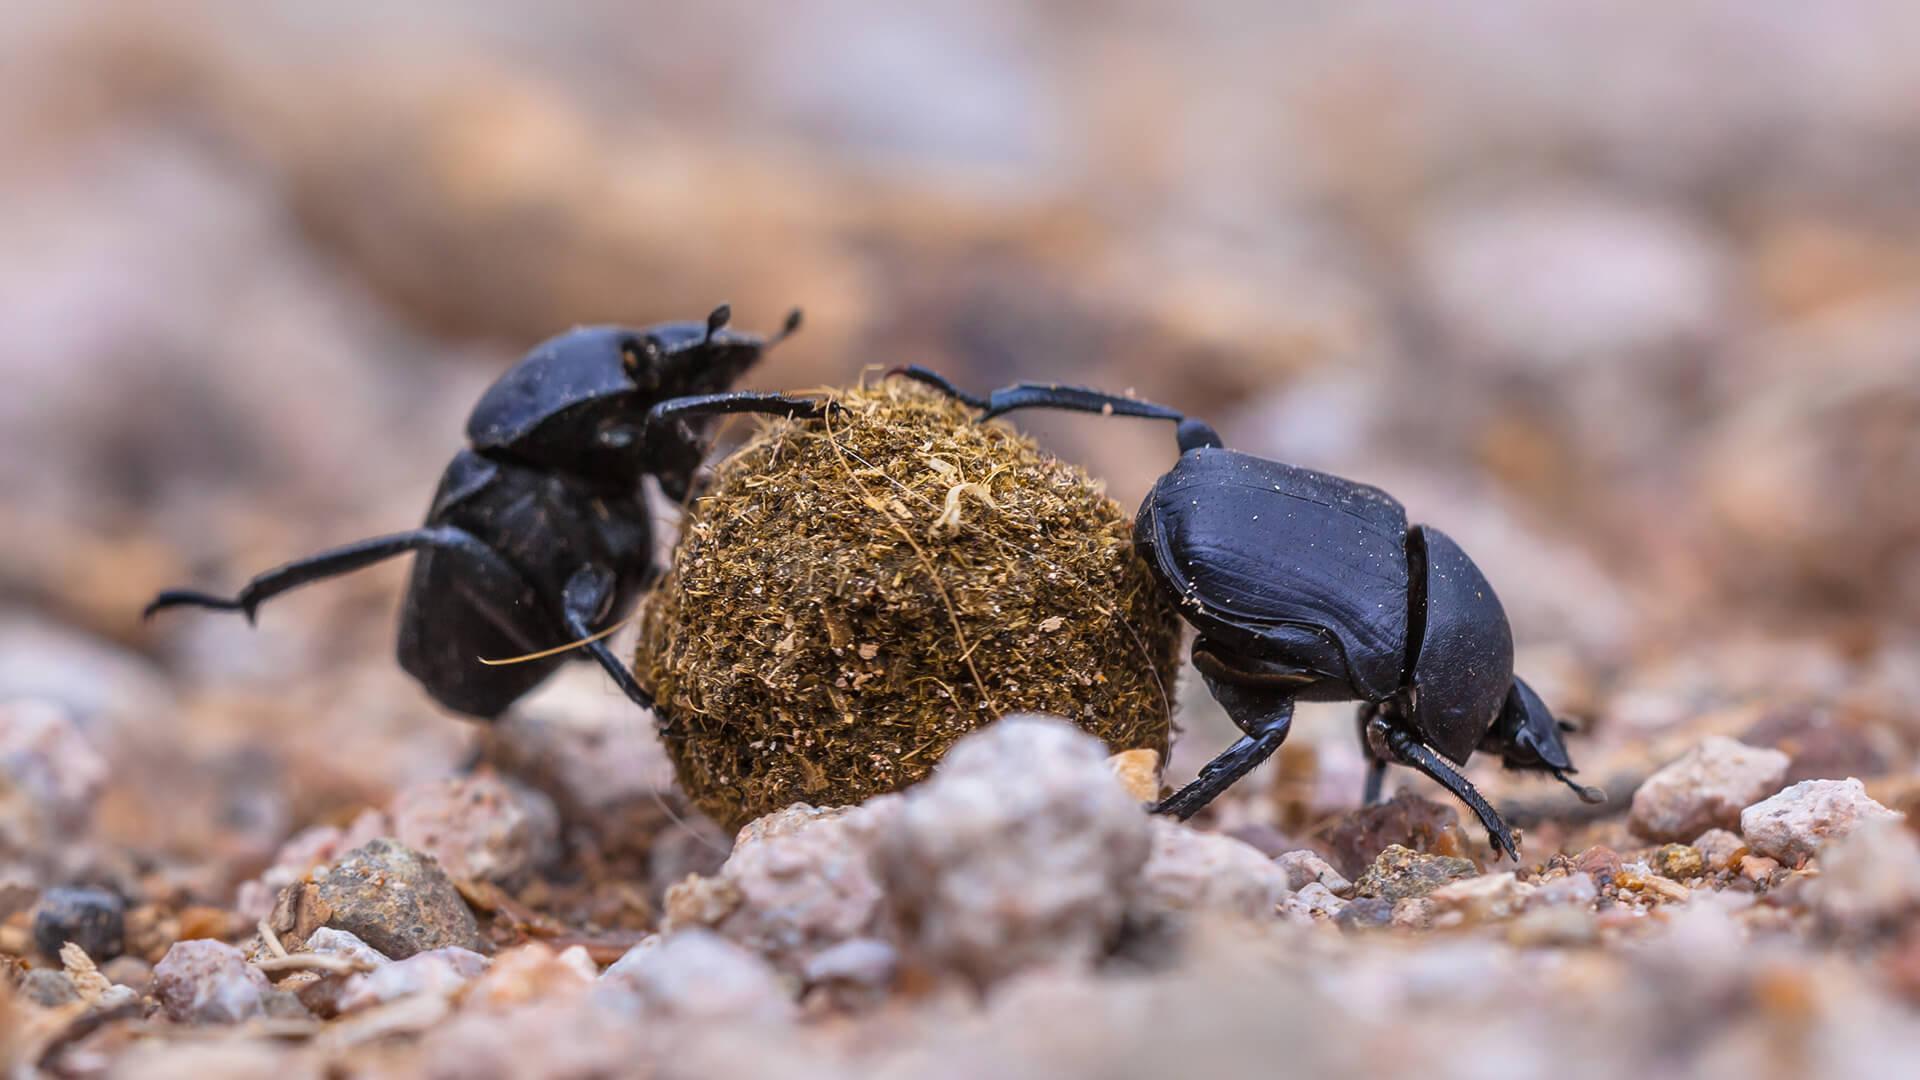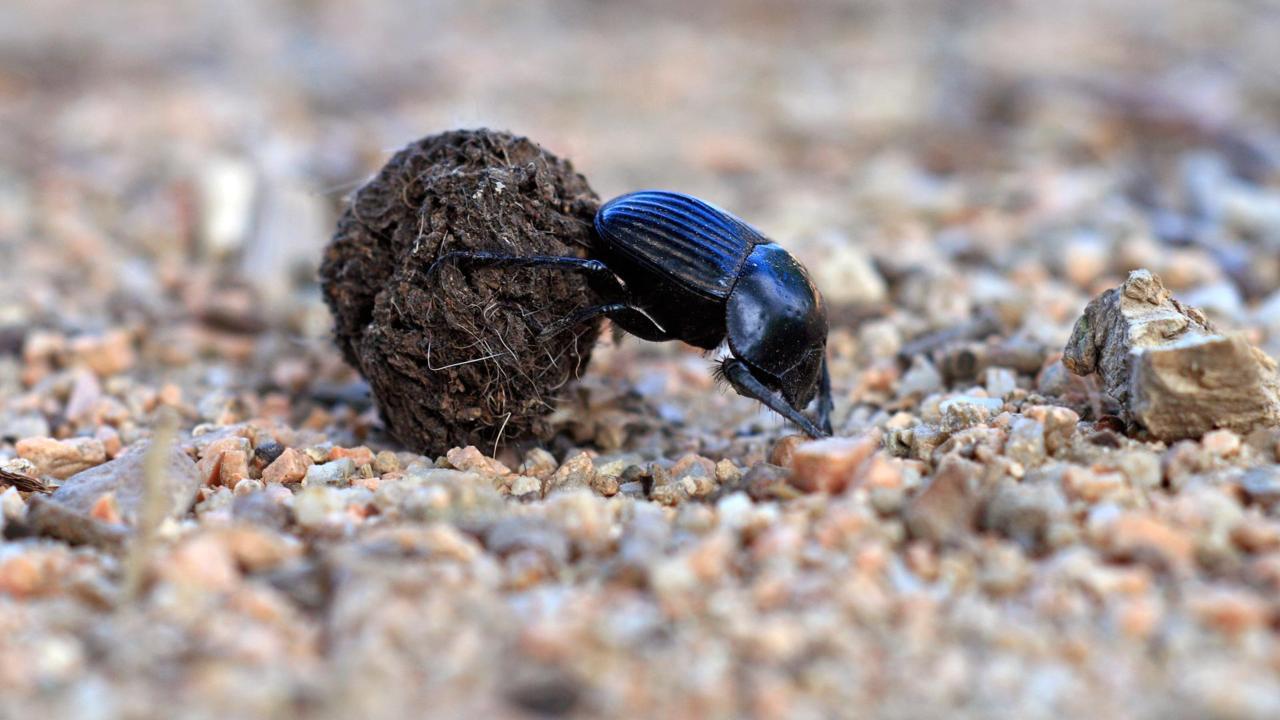The first image is the image on the left, the second image is the image on the right. For the images displayed, is the sentence "One image features two beetles on opposite sides of a dung ball." factually correct? Answer yes or no. Yes. The first image is the image on the left, the second image is the image on the right. Given the left and right images, does the statement "Two beetles are shown with a ball of dirt in one of the images." hold true? Answer yes or no. Yes. The first image is the image on the left, the second image is the image on the right. For the images displayed, is the sentence "The photos contain a total of three beetles." factually correct? Answer yes or no. Yes. 